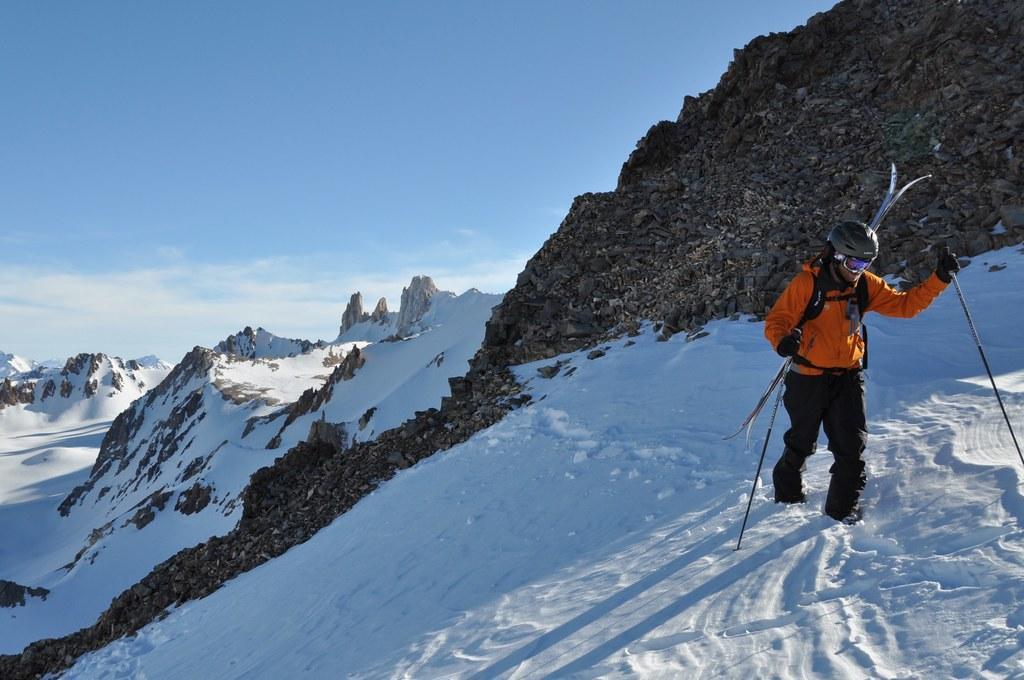In one or two sentences, can you explain what this image depicts? In this image we can see a person holding an object and we can also see mountains, snow and sky. 